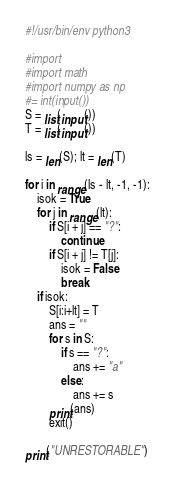Convert code to text. <code><loc_0><loc_0><loc_500><loc_500><_Python_>#!/usr/bin/env python3

#import
#import math
#import numpy as np
#= int(input())
S = list(input())
T = list(input())

ls = len(S); lt = len(T)

for i in range(ls - lt, -1, -1):
    isok = True
    for j in range(lt):
        if S[i + j] == "?":
            continue
        if S[i + j] != T[j]:
            isok = False
            break
    if isok:
        S[i:i+lt] = T
        ans = ""
        for s in S:
            if s == "?":
                ans += "a"
            else:
                ans += s
        print(ans)
        exit()

print("UNRESTORABLE")
</code> 